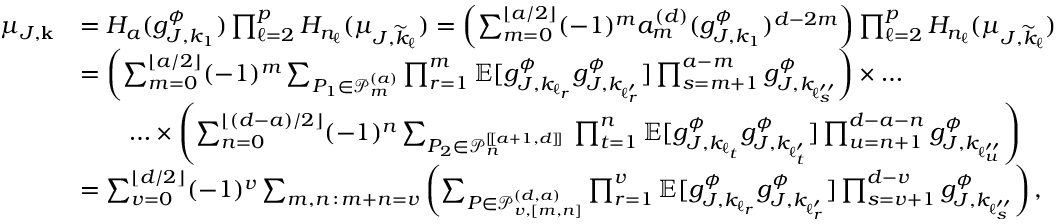Convert formula to latex. <formula><loc_0><loc_0><loc_500><loc_500>\begin{array} { r l } { \mu _ { J , k } } & { = H _ { a } ( g _ { J , k _ { 1 } } ^ { \phi } ) \prod _ { \ell = 2 } ^ { p } H _ { n _ { \ell } } ( \mu _ { J , \widetilde { k } _ { \ell } } ) = \left ( \sum _ { m = 0 } ^ { \lfloor a / 2 \rfloor } ( - 1 ) ^ { m } a _ { m } ^ { ( d ) } ( g _ { J , k _ { 1 } } ^ { \phi } ) ^ { d - 2 m } \right ) \prod _ { \ell = 2 } ^ { p } H _ { n _ { \ell } } ( \mu _ { J , \widetilde { k } _ { \ell } } ) } \\ & { = \left ( \sum _ { m = 0 } ^ { \lfloor a / 2 \rfloor } ( - 1 ) ^ { m } \sum _ { P _ { 1 } \in \mathcal { P } _ { m } ^ { ( a ) } } \prod _ { r = 1 } ^ { m } \mathbb { E } [ g _ { J , k _ { \ell _ { r } } } ^ { \phi } g _ { J , k _ { \ell _ { r } ^ { \prime } } } ^ { \phi } ] \prod _ { s = m + 1 } ^ { a - m } g _ { J , k _ { \ell _ { s } ^ { \prime \prime } } } ^ { \phi } \right ) \times \dots } \\ & { \quad \dots \times \left ( \sum _ { n = 0 } ^ { \lfloor ( d - a ) / 2 \rfloor } ( - 1 ) ^ { n } \sum _ { P _ { 2 } \in \mathcal { P } _ { n } ^ { [ \, [ a + 1 , d ] \, ] } } \, \prod _ { t = 1 } ^ { n } \mathbb { E } [ g _ { J , k _ { \ell _ { t } } } ^ { \phi } g _ { J , k _ { \ell _ { t } ^ { \prime } } } ^ { \phi } ] \prod _ { u = n + 1 } ^ { d - a - n } g _ { J , k _ { \ell _ { u } ^ { \prime \prime } } } ^ { \phi } \right ) } \\ & { = \sum _ { v = 0 } ^ { \lfloor d / 2 \rfloor } ( - 1 ) ^ { v } \sum _ { m , n \, \colon \, m + n = v } \left ( \sum _ { P \in \mathcal { P } _ { v , [ m , n ] } ^ { ( d , a ) } } \prod _ { r = 1 } ^ { v } \mathbb { E } [ g _ { J , k _ { \ell _ { r } } } ^ { \phi } g _ { J , k _ { \ell _ { r } ^ { \prime } } } ^ { \phi } ] \prod _ { s = v + 1 } ^ { d - v } g _ { J , k _ { \ell _ { s } ^ { \prime \prime } } } ^ { \phi } \right ) , } \end{array}</formula> 